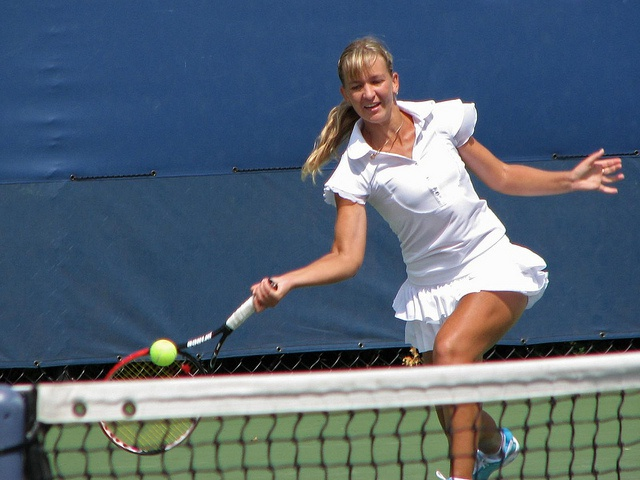Describe the objects in this image and their specific colors. I can see people in blue, white, darkgray, and brown tones, tennis racket in blue, black, white, and gray tones, and sports ball in blue, khaki, lightgreen, lightyellow, and green tones in this image. 